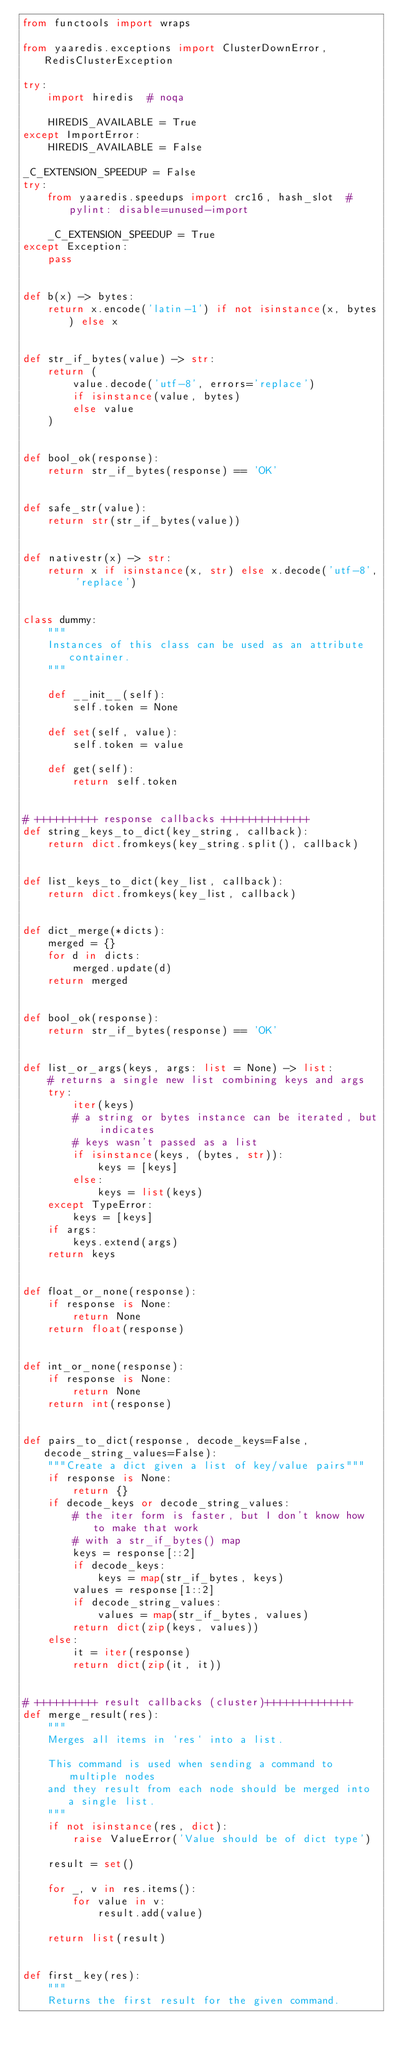<code> <loc_0><loc_0><loc_500><loc_500><_Python_>from functools import wraps

from yaaredis.exceptions import ClusterDownError, RedisClusterException

try:
    import hiredis  # noqa

    HIREDIS_AVAILABLE = True
except ImportError:
    HIREDIS_AVAILABLE = False

_C_EXTENSION_SPEEDUP = False
try:
    from yaaredis.speedups import crc16, hash_slot  # pylint: disable=unused-import

    _C_EXTENSION_SPEEDUP = True
except Exception:
    pass


def b(x) -> bytes:
    return x.encode('latin-1') if not isinstance(x, bytes) else x


def str_if_bytes(value) -> str:
    return (
        value.decode('utf-8', errors='replace')
        if isinstance(value, bytes)
        else value
    )


def bool_ok(response):
    return str_if_bytes(response) == 'OK'


def safe_str(value):
    return str(str_if_bytes(value))


def nativestr(x) -> str:
    return x if isinstance(x, str) else x.decode('utf-8', 'replace')


class dummy:
    """
    Instances of this class can be used as an attribute container.
    """

    def __init__(self):
        self.token = None

    def set(self, value):
        self.token = value

    def get(self):
        return self.token


# ++++++++++ response callbacks ++++++++++++++
def string_keys_to_dict(key_string, callback):
    return dict.fromkeys(key_string.split(), callback)


def list_keys_to_dict(key_list, callback):
    return dict.fromkeys(key_list, callback)


def dict_merge(*dicts):
    merged = {}
    for d in dicts:
        merged.update(d)
    return merged


def bool_ok(response):
    return str_if_bytes(response) == 'OK'


def list_or_args(keys, args: list = None) -> list:
    # returns a single new list combining keys and args
    try:
        iter(keys)
        # a string or bytes instance can be iterated, but indicates
        # keys wasn't passed as a list
        if isinstance(keys, (bytes, str)):
            keys = [keys]
        else:
            keys = list(keys)
    except TypeError:
        keys = [keys]
    if args:
        keys.extend(args)
    return keys


def float_or_none(response):
    if response is None:
        return None
    return float(response)


def int_or_none(response):
    if response is None:
        return None
    return int(response)


def pairs_to_dict(response, decode_keys=False, decode_string_values=False):
    """Create a dict given a list of key/value pairs"""
    if response is None:
        return {}
    if decode_keys or decode_string_values:
        # the iter form is faster, but I don't know how to make that work
        # with a str_if_bytes() map
        keys = response[::2]
        if decode_keys:
            keys = map(str_if_bytes, keys)
        values = response[1::2]
        if decode_string_values:
            values = map(str_if_bytes, values)
        return dict(zip(keys, values))
    else:
        it = iter(response)
        return dict(zip(it, it))


# ++++++++++ result callbacks (cluster)++++++++++++++
def merge_result(res):
    """
    Merges all items in `res` into a list.

    This command is used when sending a command to multiple nodes
    and they result from each node should be merged into a single list.
    """
    if not isinstance(res, dict):
        raise ValueError('Value should be of dict type')

    result = set()

    for _, v in res.items():
        for value in v:
            result.add(value)

    return list(result)


def first_key(res):
    """
    Returns the first result for the given command.
</code> 